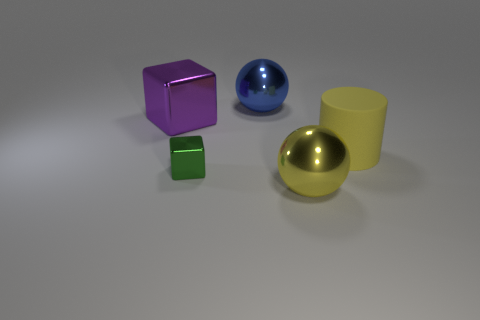What is the size of the purple cube that is on the left side of the big metallic sphere that is behind the yellow thing that is in front of the yellow matte object?
Ensure brevity in your answer.  Large. Is the big block made of the same material as the sphere that is on the right side of the large blue ball?
Provide a succinct answer. Yes. Is the shape of the big yellow metal thing the same as the blue metallic object?
Make the answer very short. Yes. What number of other things are there of the same material as the big blue object
Offer a very short reply. 3. What number of big gray rubber objects are the same shape as the large purple object?
Provide a short and direct response. 0. There is a thing that is both in front of the yellow rubber object and on the right side of the blue thing; what color is it?
Give a very brief answer. Yellow. What number of yellow things are there?
Give a very brief answer. 2. Does the green object have the same size as the yellow sphere?
Keep it short and to the point. No. Are there any tiny metallic spheres that have the same color as the large matte thing?
Offer a very short reply. No. There is a object that is to the right of the large yellow metallic object; is its shape the same as the tiny green metallic object?
Give a very brief answer. No. 